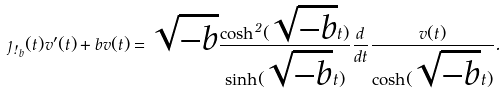Convert formula to latex. <formula><loc_0><loc_0><loc_500><loc_500>\eta _ { \omega _ { b } } ( t ) v ^ { \prime } ( t ) + b v ( t ) = \sqrt { - b } \frac { \cosh ^ { 2 } ( \sqrt { - b } t ) } { \sinh ( \sqrt { - b } t ) } \frac { d } { d t } \frac { v ( t ) } { \cosh ( \sqrt { - b } t ) } .</formula> 